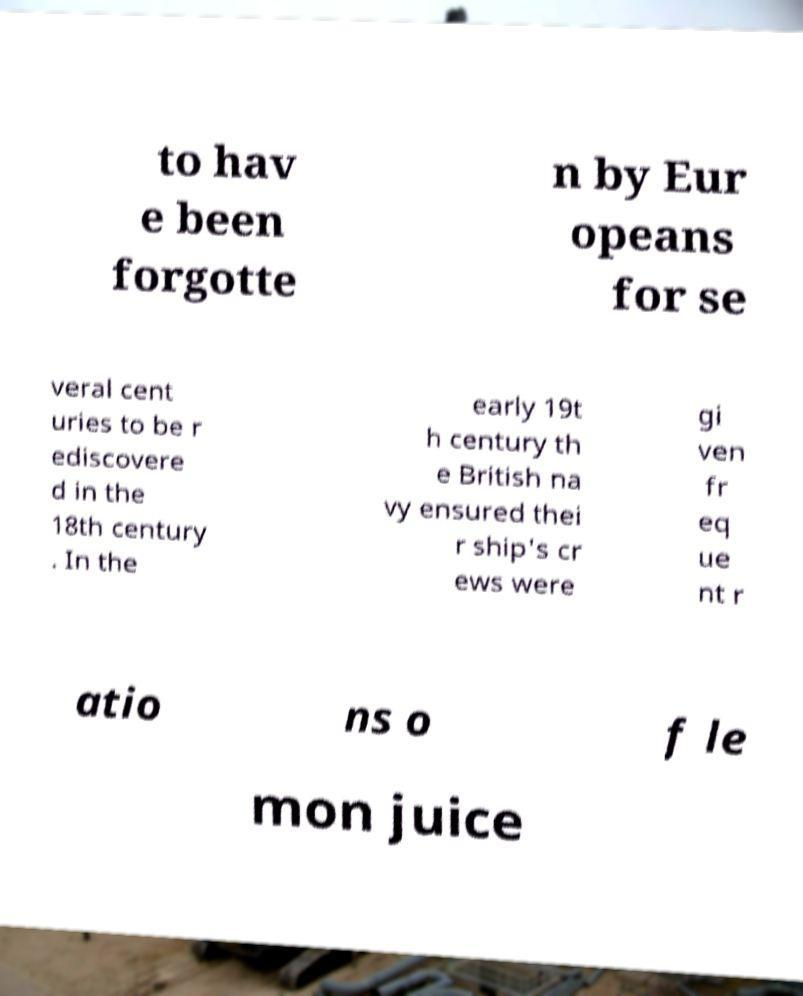Please identify and transcribe the text found in this image. to hav e been forgotte n by Eur opeans for se veral cent uries to be r ediscovere d in the 18th century . In the early 19t h century th e British na vy ensured thei r ship's cr ews were gi ven fr eq ue nt r atio ns o f le mon juice 